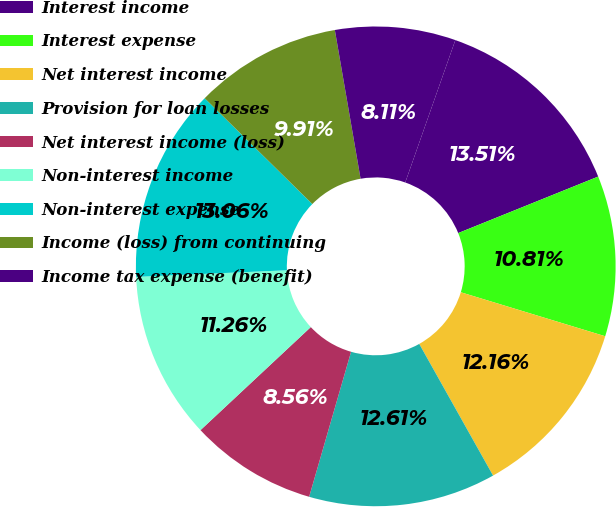Convert chart. <chart><loc_0><loc_0><loc_500><loc_500><pie_chart><fcel>Interest income<fcel>Interest expense<fcel>Net interest income<fcel>Provision for loan losses<fcel>Net interest income (loss)<fcel>Non-interest income<fcel>Non-interest expense<fcel>Income (loss) from continuing<fcel>Income tax expense (benefit)<nl><fcel>13.51%<fcel>10.81%<fcel>12.16%<fcel>12.61%<fcel>8.56%<fcel>11.26%<fcel>13.06%<fcel>9.91%<fcel>8.11%<nl></chart> 